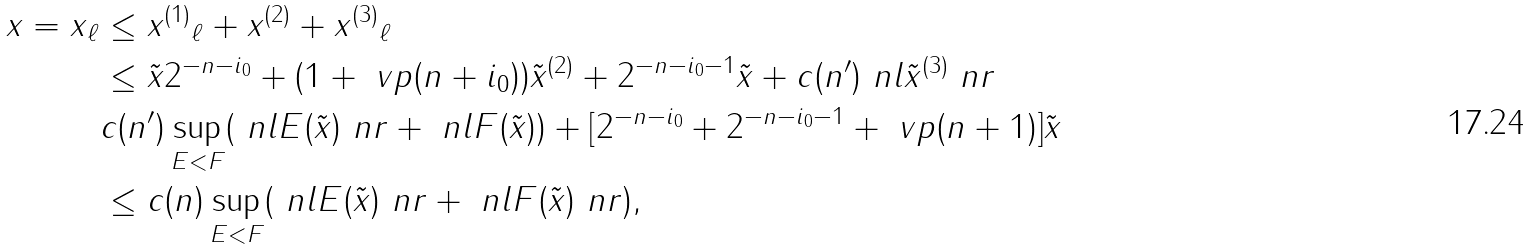Convert formula to latex. <formula><loc_0><loc_0><loc_500><loc_500>\| x \| = \| x \| _ { \ell } & \leq \| x ^ { ( 1 ) } \| _ { \ell } + \| x ^ { ( 2 ) } \| + \| x ^ { ( 3 ) } \| _ { \ell } \\ & \leq \| \tilde { x } \| 2 ^ { - n - i _ { 0 } } + ( 1 + \ v p ( n + i _ { 0 } ) ) \| \tilde { x } ^ { ( 2 ) } \| + 2 ^ { - n - i _ { 0 } - 1 } \| \tilde { x } \| + c ( n ^ { \prime } ) \ n l \tilde { x } ^ { ( 3 ) } \ n r \\ & c ( n ^ { \prime } ) \sup _ { E < F } ( \ n l E ( \tilde { x } ) \ n r + \ n l F ( \tilde { x } ) ) + [ 2 ^ { - n - i _ { 0 } } + 2 ^ { - n - i _ { 0 } - 1 } + \ v p ( n + 1 ) ] \| \tilde { x } \| \\ & \leq c ( n ) \sup _ { E < F } ( \ n l E ( \tilde { x } ) \ n r + \ n l F ( \tilde { x } ) \ n r ) ,</formula> 